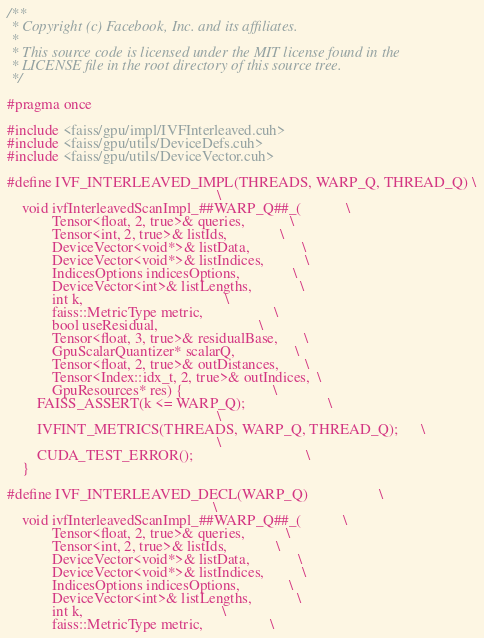<code> <loc_0><loc_0><loc_500><loc_500><_Cuda_>/**
 * Copyright (c) Facebook, Inc. and its affiliates.
 *
 * This source code is licensed under the MIT license found in the
 * LICENSE file in the root directory of this source tree.
 */

#pragma once

#include <faiss/gpu/impl/IVFInterleaved.cuh>
#include <faiss/gpu/utils/DeviceDefs.cuh>
#include <faiss/gpu/utils/DeviceVector.cuh>

#define IVF_INTERLEAVED_IMPL(THREADS, WARP_Q, THREAD_Q) \
                                                        \
    void ivfInterleavedScanImpl_##WARP_Q##_(            \
            Tensor<float, 2, true>& queries,            \
            Tensor<int, 2, true>& listIds,              \
            DeviceVector<void*>& listData,              \
            DeviceVector<void*>& listIndices,           \
            IndicesOptions indicesOptions,              \
            DeviceVector<int>& listLengths,             \
            int k,                                      \
            faiss::MetricType metric,                   \
            bool useResidual,                           \
            Tensor<float, 3, true>& residualBase,       \
            GpuScalarQuantizer* scalarQ,                \
            Tensor<float, 2, true>& outDistances,       \
            Tensor<Index::idx_t, 2, true>& outIndices,  \
            GpuResources* res) {                        \
        FAISS_ASSERT(k <= WARP_Q);                      \
                                                        \
        IVFINT_METRICS(THREADS, WARP_Q, THREAD_Q);      \
                                                        \
        CUDA_TEST_ERROR();                              \
    }

#define IVF_INTERLEAVED_DECL(WARP_Q)                   \
                                                       \
    void ivfInterleavedScanImpl_##WARP_Q##_(           \
            Tensor<float, 2, true>& queries,           \
            Tensor<int, 2, true>& listIds,             \
            DeviceVector<void*>& listData,             \
            DeviceVector<void*>& listIndices,          \
            IndicesOptions indicesOptions,             \
            DeviceVector<int>& listLengths,            \
            int k,                                     \
            faiss::MetricType metric,                  \</code> 